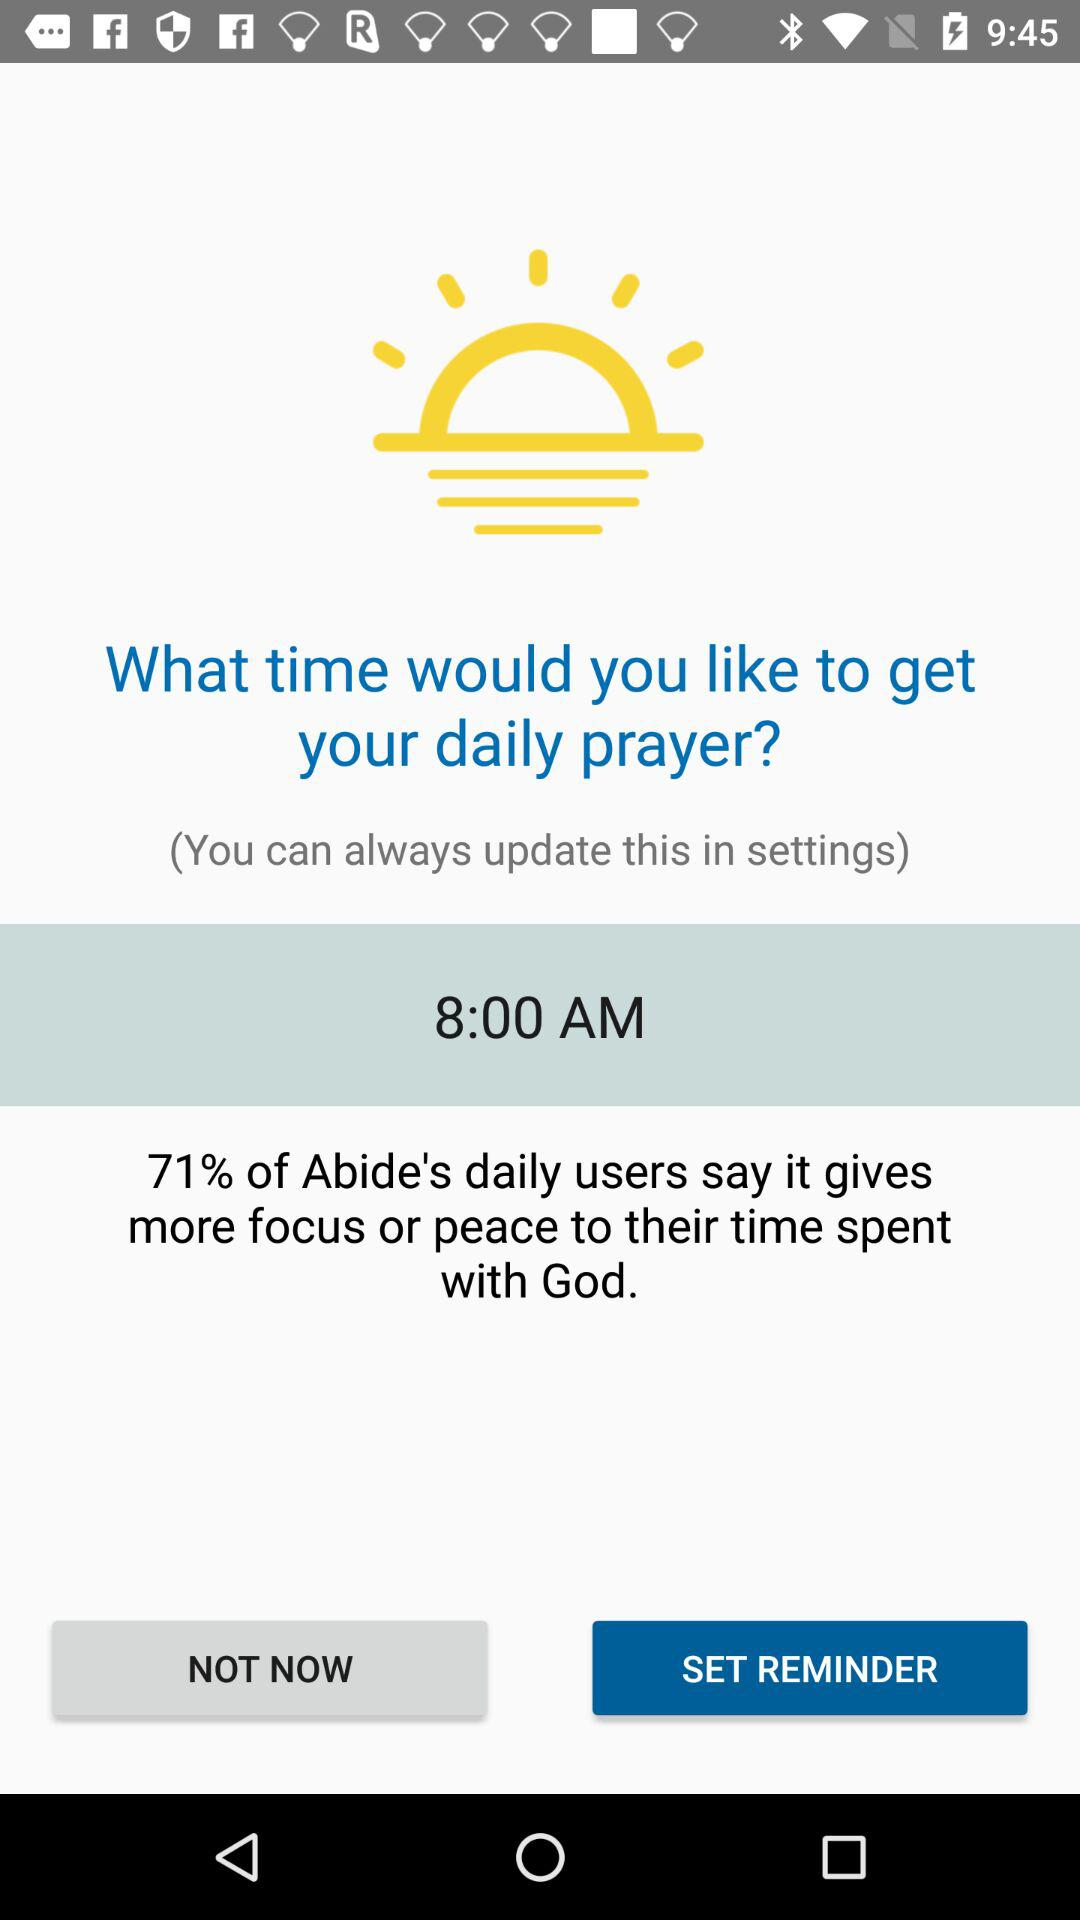How many percent of Abide's daily users believe that spending time with God helps them to be more focused and at peace? There are 71% of Abide's daily users who believe that spending time with God helps them to be more focused and at peace. 